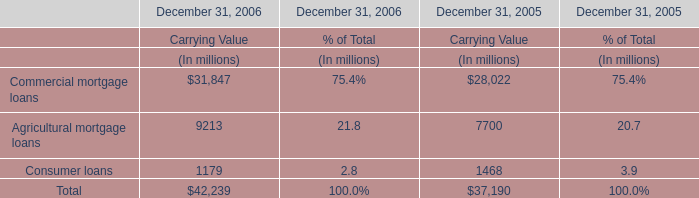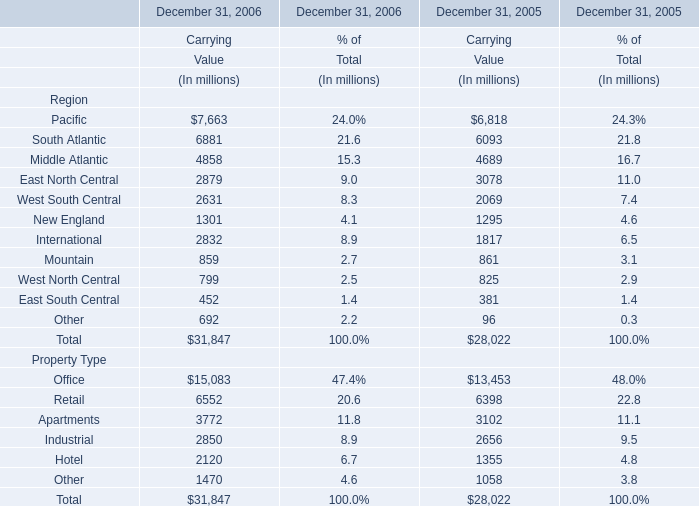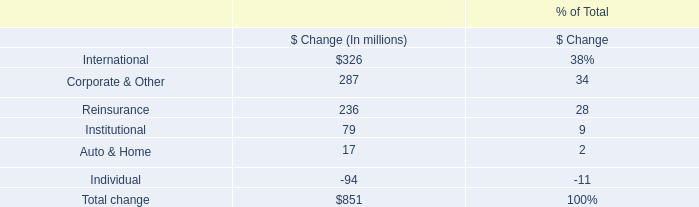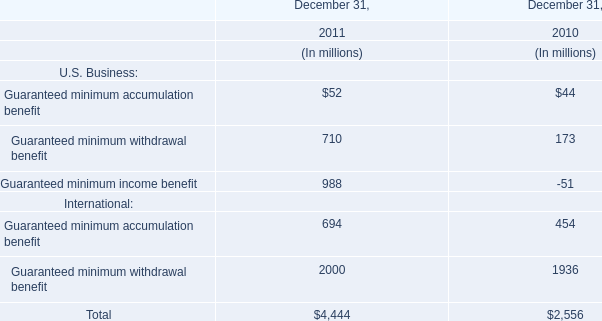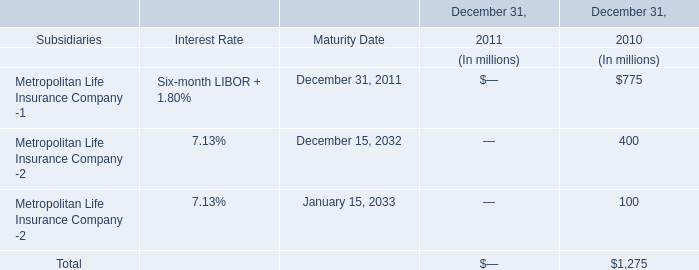What's the sum of all Region that are greater than 5000 in 2006? (in million) 
Computations: ((((7663 + 6881) + 31847) + 15083) + 6552)
Answer: 68026.0. 